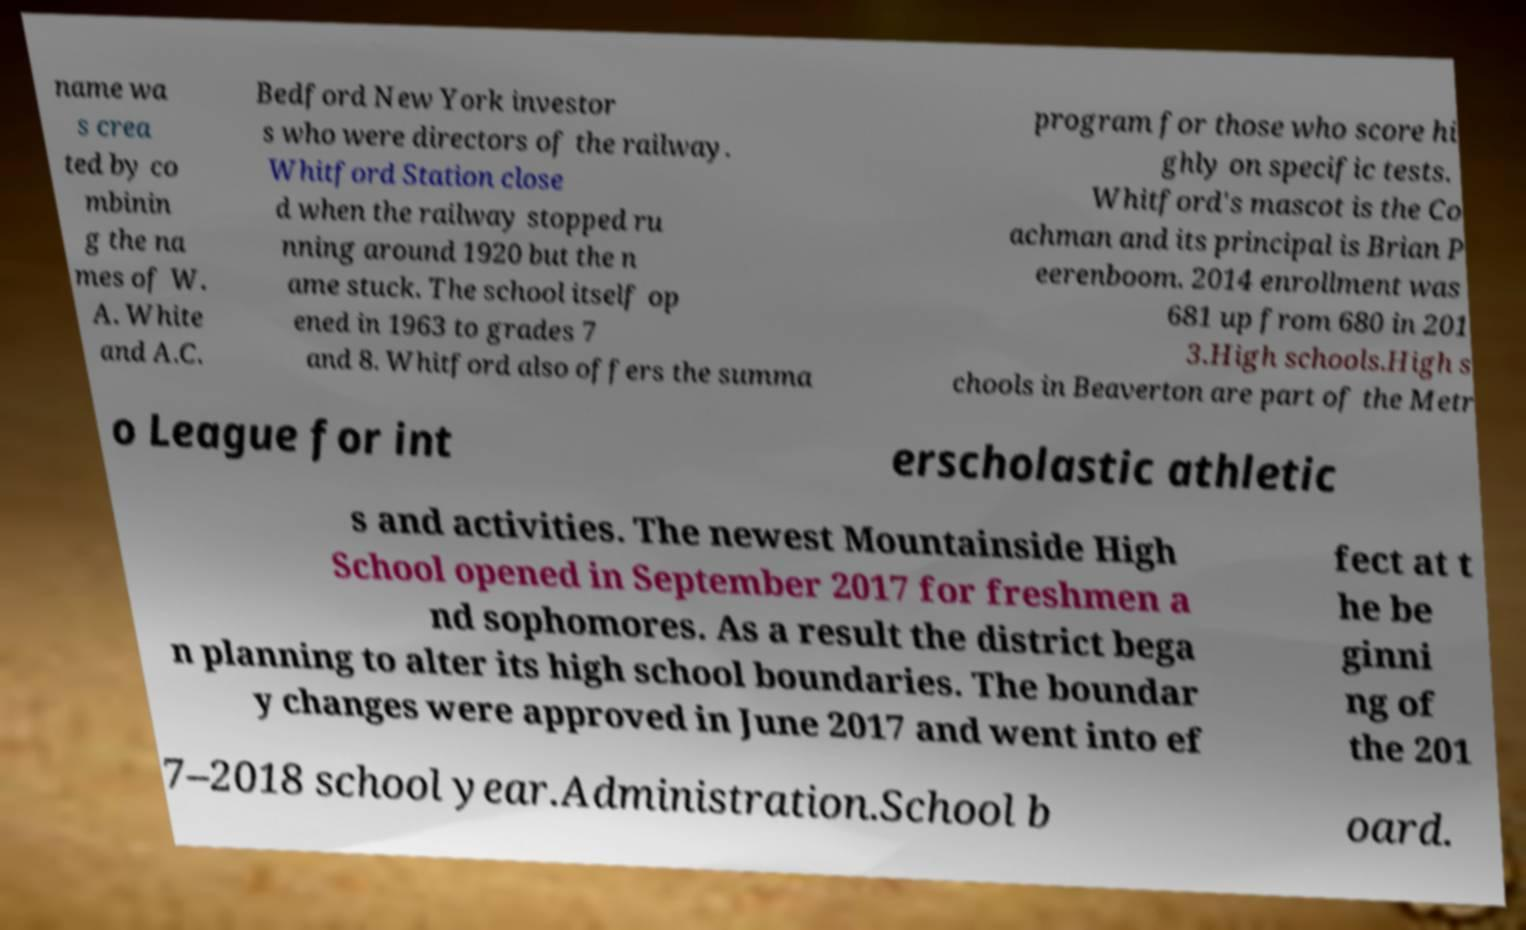Please identify and transcribe the text found in this image. name wa s crea ted by co mbinin g the na mes of W. A. White and A.C. Bedford New York investor s who were directors of the railway. Whitford Station close d when the railway stopped ru nning around 1920 but the n ame stuck. The school itself op ened in 1963 to grades 7 and 8. Whitford also offers the summa program for those who score hi ghly on specific tests. Whitford's mascot is the Co achman and its principal is Brian P eerenboom. 2014 enrollment was 681 up from 680 in 201 3.High schools.High s chools in Beaverton are part of the Metr o League for int erscholastic athletic s and activities. The newest Mountainside High School opened in September 2017 for freshmen a nd sophomores. As a result the district bega n planning to alter its high school boundaries. The boundar y changes were approved in June 2017 and went into ef fect at t he be ginni ng of the 201 7–2018 school year.Administration.School b oard. 